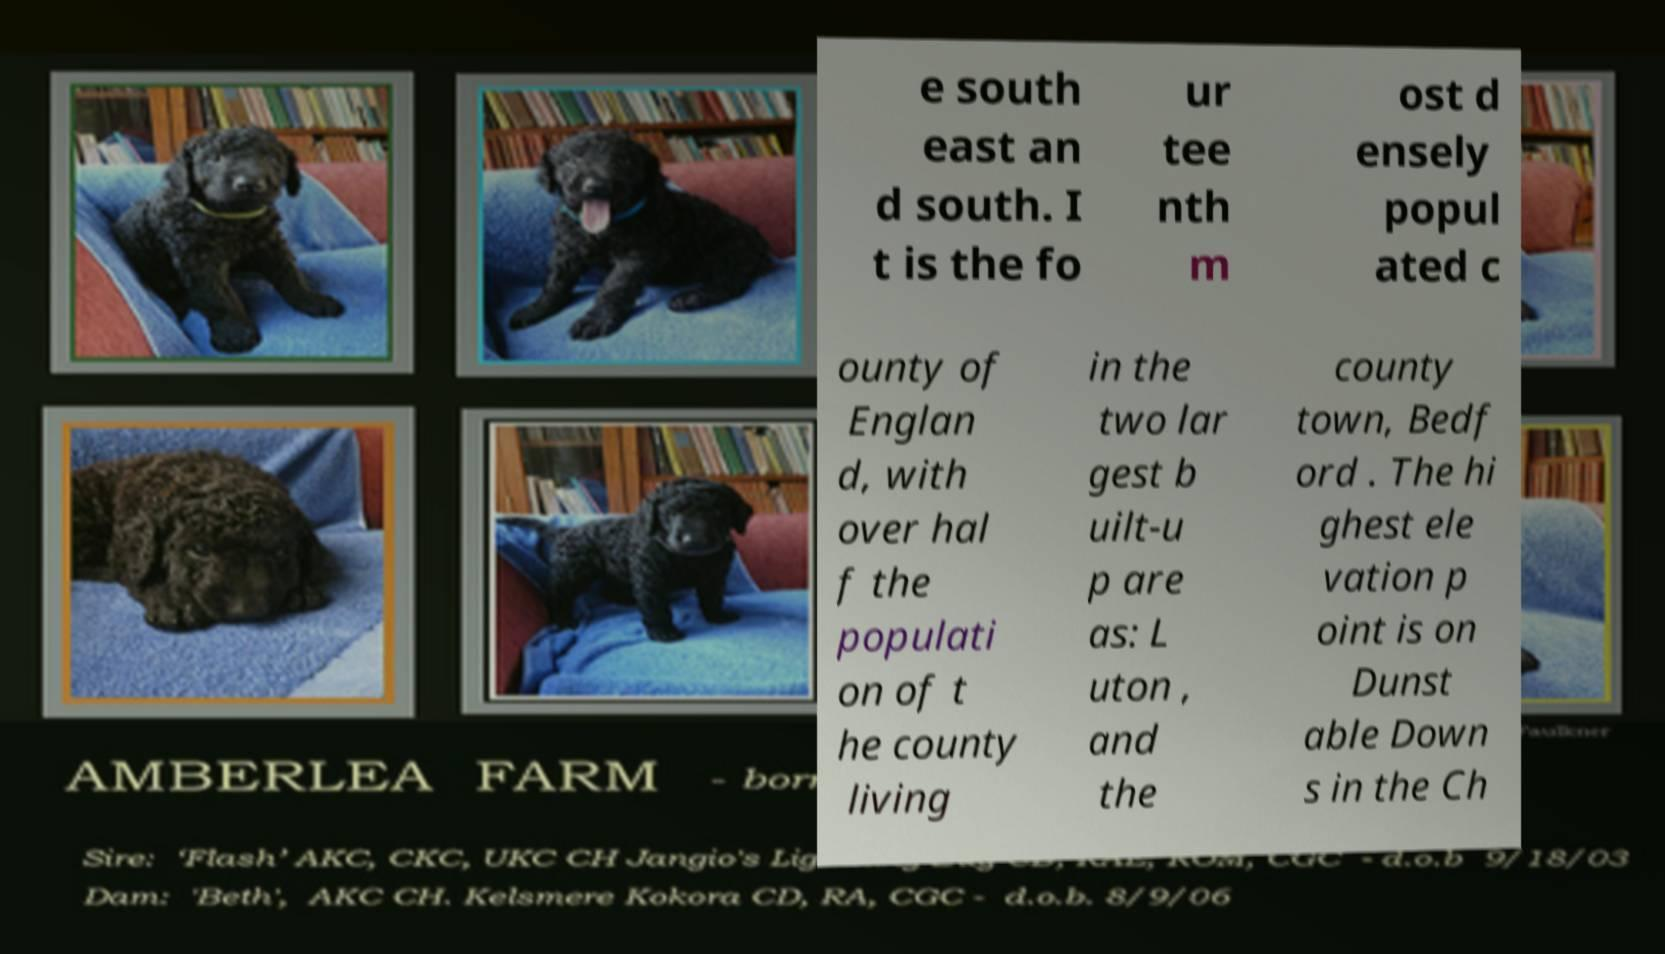Could you extract and type out the text from this image? e south east an d south. I t is the fo ur tee nth m ost d ensely popul ated c ounty of Englan d, with over hal f the populati on of t he county living in the two lar gest b uilt-u p are as: L uton , and the county town, Bedf ord . The hi ghest ele vation p oint is on Dunst able Down s in the Ch 